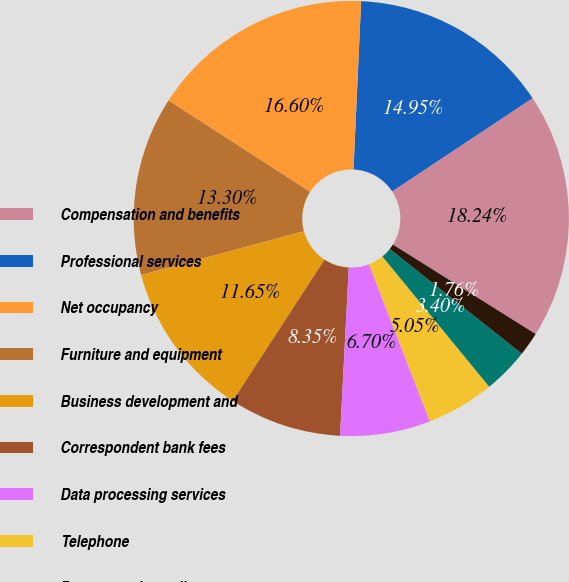Convert chart. <chart><loc_0><loc_0><loc_500><loc_500><pie_chart><fcel>Compensation and benefits<fcel>Professional services<fcel>Net occupancy<fcel>Furniture and equipment<fcel>Business development and<fcel>Correspondent bank fees<fcel>Data processing services<fcel>Telephone<fcel>Postage and supplies<fcel>Tax credit fund amortization<nl><fcel>18.24%<fcel>14.95%<fcel>16.6%<fcel>13.3%<fcel>11.65%<fcel>8.35%<fcel>6.7%<fcel>5.05%<fcel>3.4%<fcel>1.76%<nl></chart> 